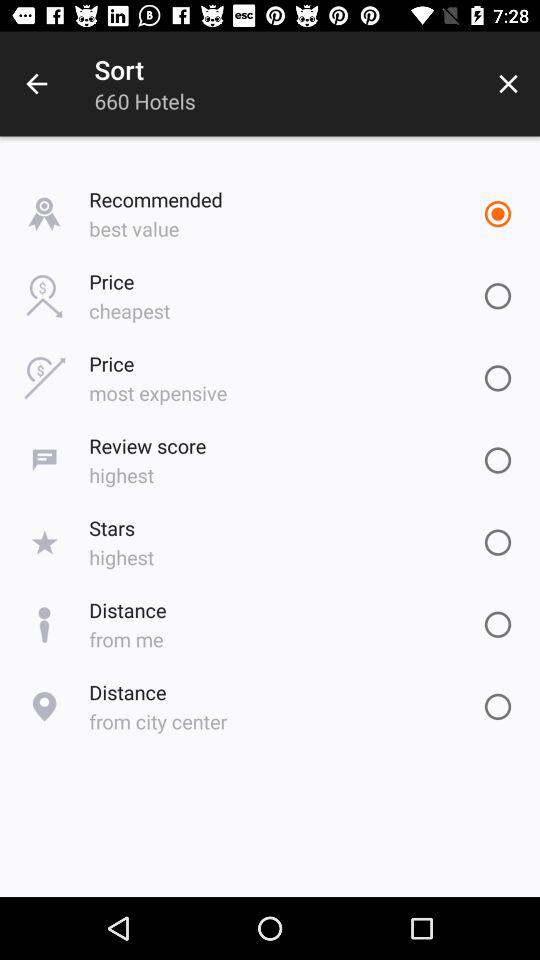What are the different choices given for sorting? The different choices given for sorting are "Recommended", "Price", "Review score", "Stars" and "Distance". 